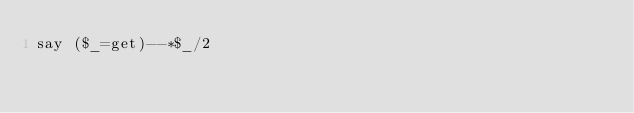Convert code to text. <code><loc_0><loc_0><loc_500><loc_500><_Perl_>say ($_=get)--*$_/2</code> 